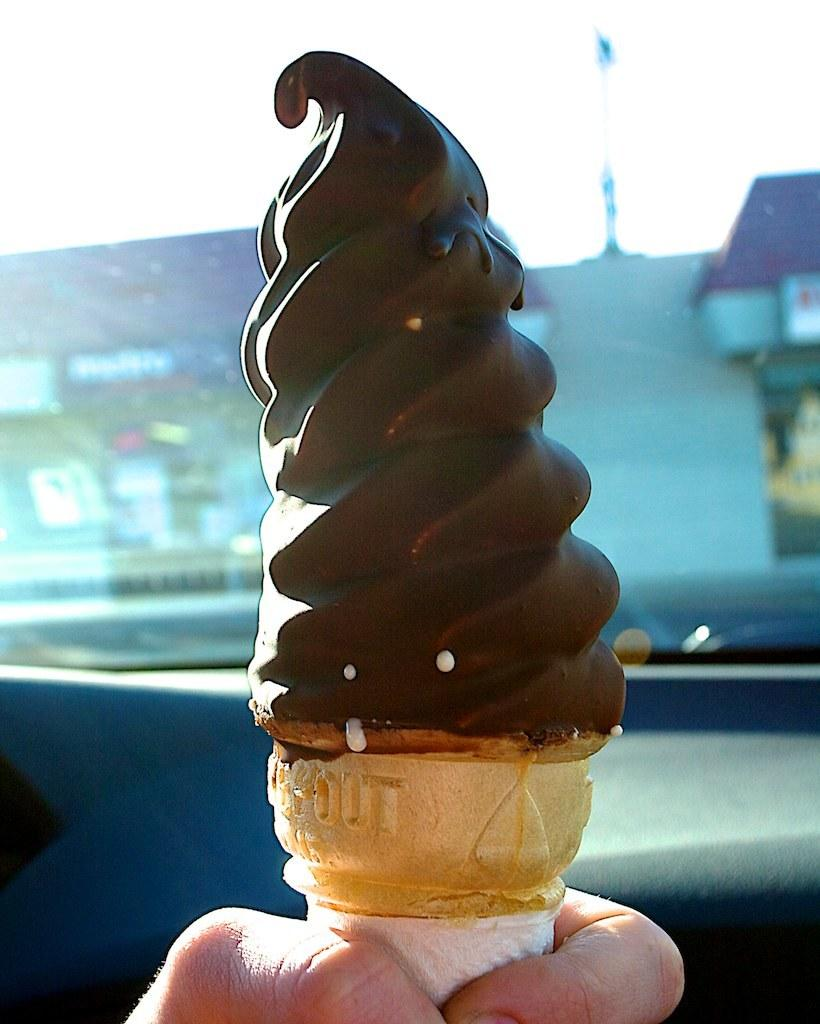What is the person in the foreground of the picture holding? The person is holding ice cream in the foreground of the picture. What can be seen in the background of the picture? There is a vehicle mirror in the background of the picture, and buildings are visible outside the mirror. How would you describe the weather in the image? The weather is sunny in the image. Is there an earthquake happening in the image? No, there is no indication of an earthquake in the image. Are the people in the image talking to each other? The image does not show any people talking to each other, as it only features a person holding ice cream and a vehicle mirror with buildings visible outside. 